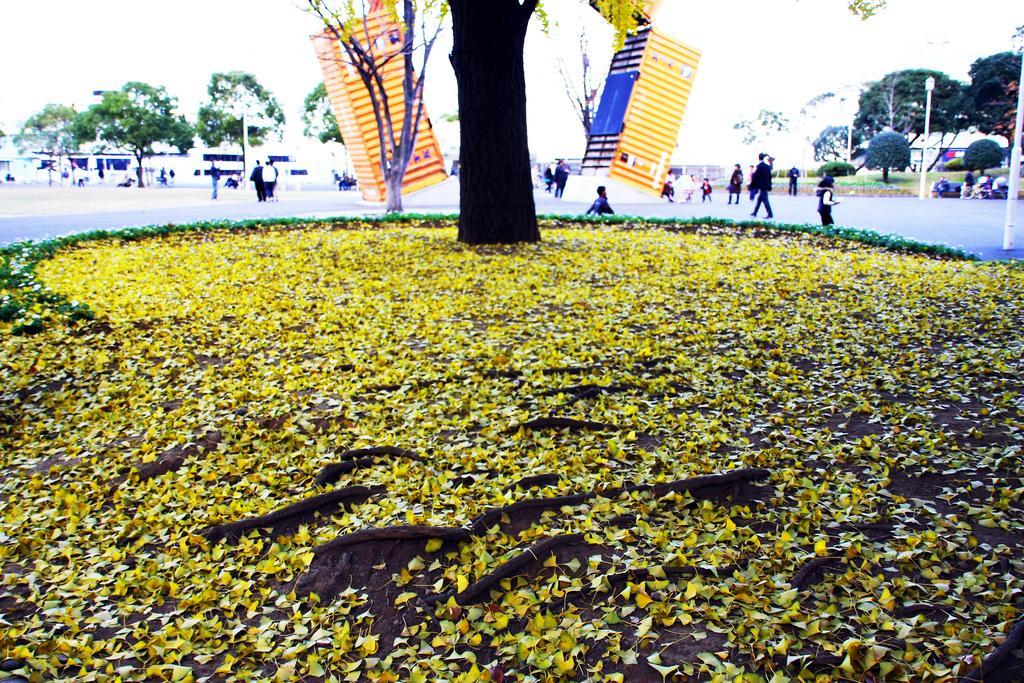In one or two sentences, can you explain what this image depicts? In the center of the image we can see trees, grass, leaves and a few other objects. And we can see the leaves are in yellow color. In the background, we can see the sky, poles, trees, banners, buildings, few people are walking, few people are standing, few people are sitting, few people are holding some objects and a few other objects. 